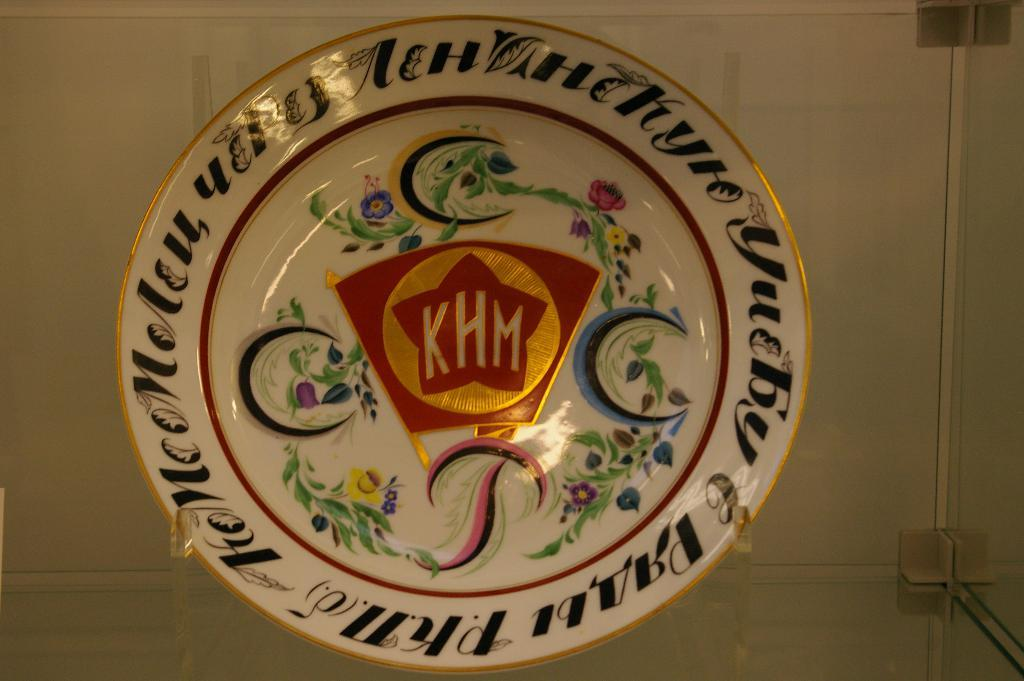What can be seen hanging in the image? There is a glass rack in the image. What type of plate is visible in the image? There is a designed plate with text and painting in the image. How is the designed plate positioned in the image? The designed plate is placed on a stand. Can you see any sea creatures swimming around the glass rack in the image? There are no sea creatures visible in the image; it features a glass rack and a designed plate. Where is the nest located in the image? There is no nest present in the image. 